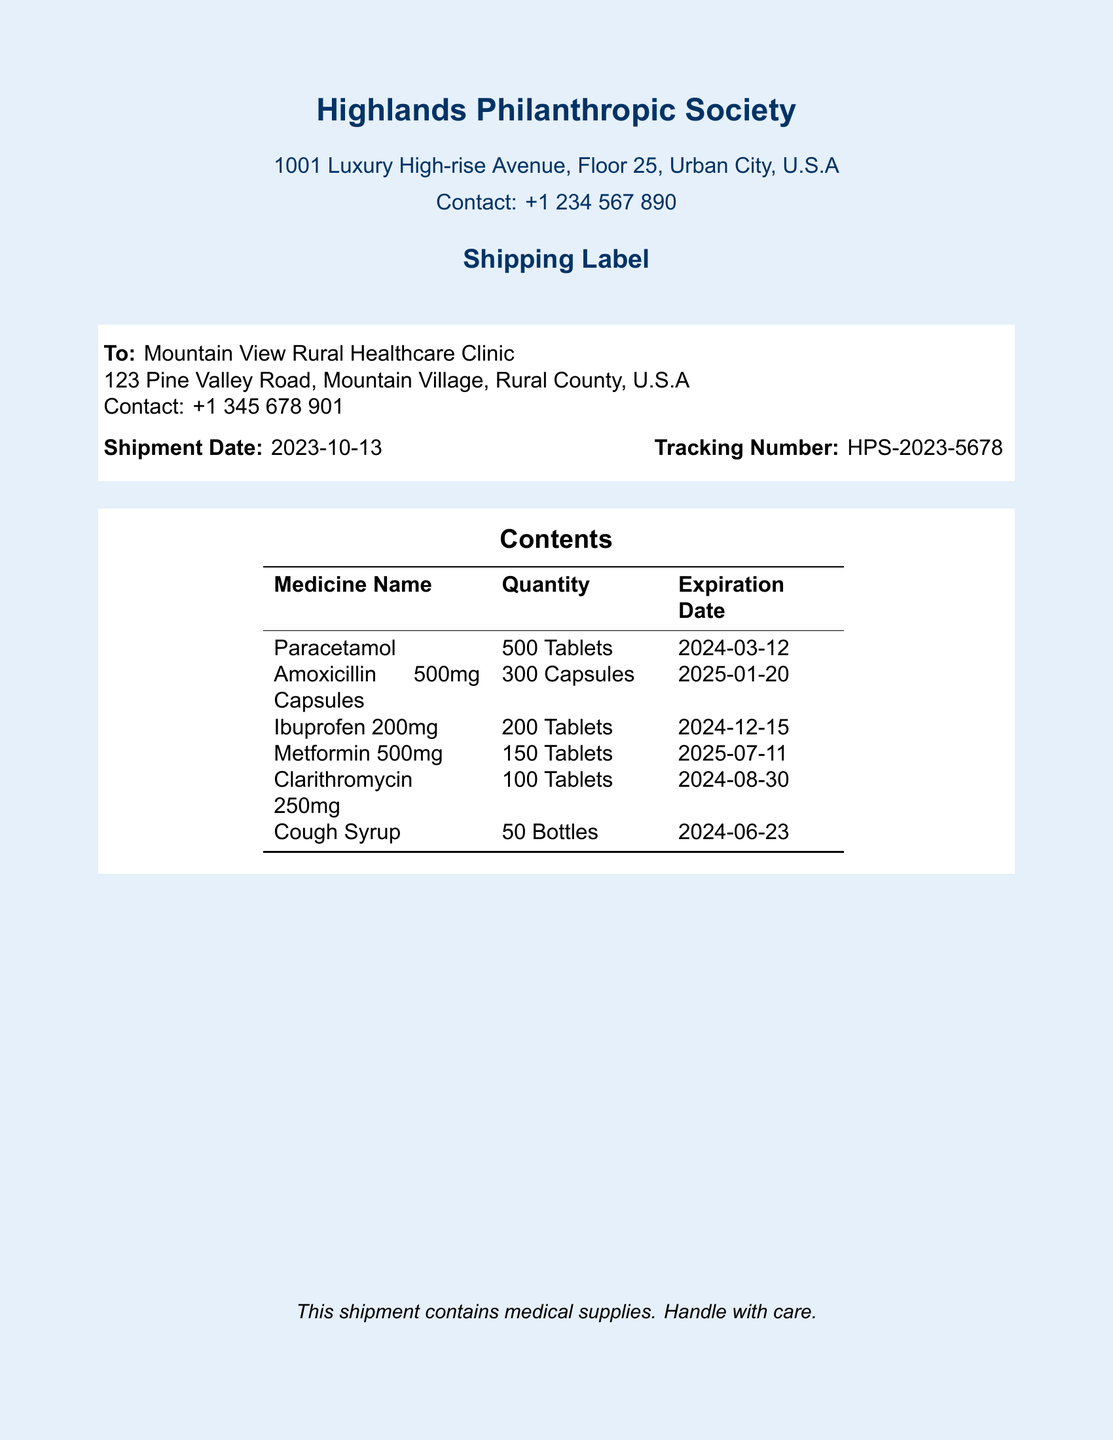What is the recipient's organization name? The recipient's organization name is listed as "Mountain View Rural Healthcare Clinic" in the "To" section of the shipping label.
Answer: Mountain View Rural Healthcare Clinic What is the shipment date? The shipment date is mentioned in the document under the "Shipment Date" section.
Answer: 2023-10-13 How many Paracetamol tablets are included in the shipment? The quantity of Paracetamol tablets is specified in the "Contents" table of the shipping label.
Answer: 500 Tablets What is the expiration date of the Amoxicillin capsules? The expiration date can be found in the "Contents" table next to the Amoxicillin entry.
Answer: 2025-01-20 What is the tracking number for this shipment? The tracking number is indicated in the "Tracking Number" section of the shipping label.
Answer: HPS-2023-5678 How many Bottles of Cough Syrup are included? The number of Cough Syrup bottles is specified in the "Contents" table of the shipping label.
Answer: 50 Bottles What type of document is this? The document is identified as a shipping label, highlighted prominently at the top of the document.
Answer: Shipping Label Which medicine has the earliest expiration date? To determine this, one must compare the expiration dates listed in the "Contents" table; the earliest is indicated next to Paracetamol.
Answer: 2024-03-12 What organization is sending the medical supplies? The sending organization is stated at the top of the document under "Highlands Philanthropic Society."
Answer: Highlands Philanthropic Society 